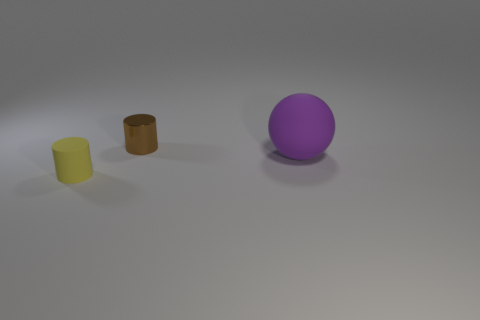Add 3 brown cylinders. How many objects exist? 6 Subtract all balls. How many objects are left? 2 Add 3 big rubber things. How many big rubber things exist? 4 Subtract 1 yellow cylinders. How many objects are left? 2 Subtract all big purple balls. Subtract all small things. How many objects are left? 0 Add 3 brown objects. How many brown objects are left? 4 